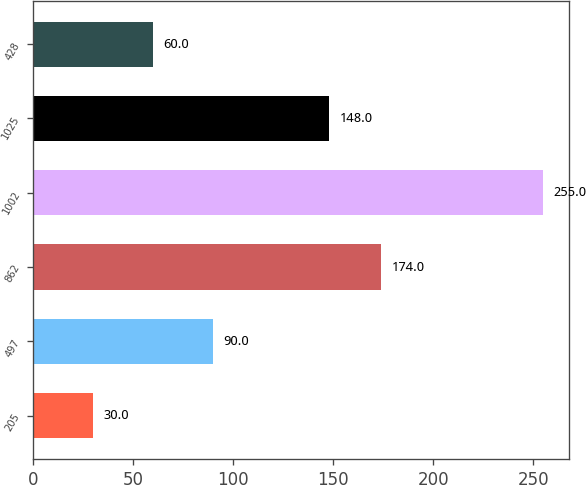<chart> <loc_0><loc_0><loc_500><loc_500><bar_chart><fcel>205<fcel>497<fcel>862<fcel>1002<fcel>1025<fcel>428<nl><fcel>30<fcel>90<fcel>174<fcel>255<fcel>148<fcel>60<nl></chart> 